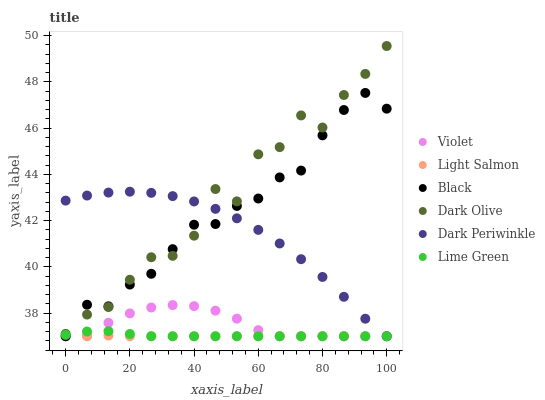Does Light Salmon have the minimum area under the curve?
Answer yes or no. Yes. Does Dark Olive have the maximum area under the curve?
Answer yes or no. Yes. Does Black have the minimum area under the curve?
Answer yes or no. No. Does Black have the maximum area under the curve?
Answer yes or no. No. Is Light Salmon the smoothest?
Answer yes or no. Yes. Is Dark Olive the roughest?
Answer yes or no. Yes. Is Black the smoothest?
Answer yes or no. No. Is Black the roughest?
Answer yes or no. No. Does Light Salmon have the lowest value?
Answer yes or no. Yes. Does Dark Olive have the lowest value?
Answer yes or no. No. Does Dark Olive have the highest value?
Answer yes or no. Yes. Does Black have the highest value?
Answer yes or no. No. Is Light Salmon less than Dark Olive?
Answer yes or no. Yes. Is Dark Olive greater than Lime Green?
Answer yes or no. Yes. Does Black intersect Violet?
Answer yes or no. Yes. Is Black less than Violet?
Answer yes or no. No. Is Black greater than Violet?
Answer yes or no. No. Does Light Salmon intersect Dark Olive?
Answer yes or no. No. 